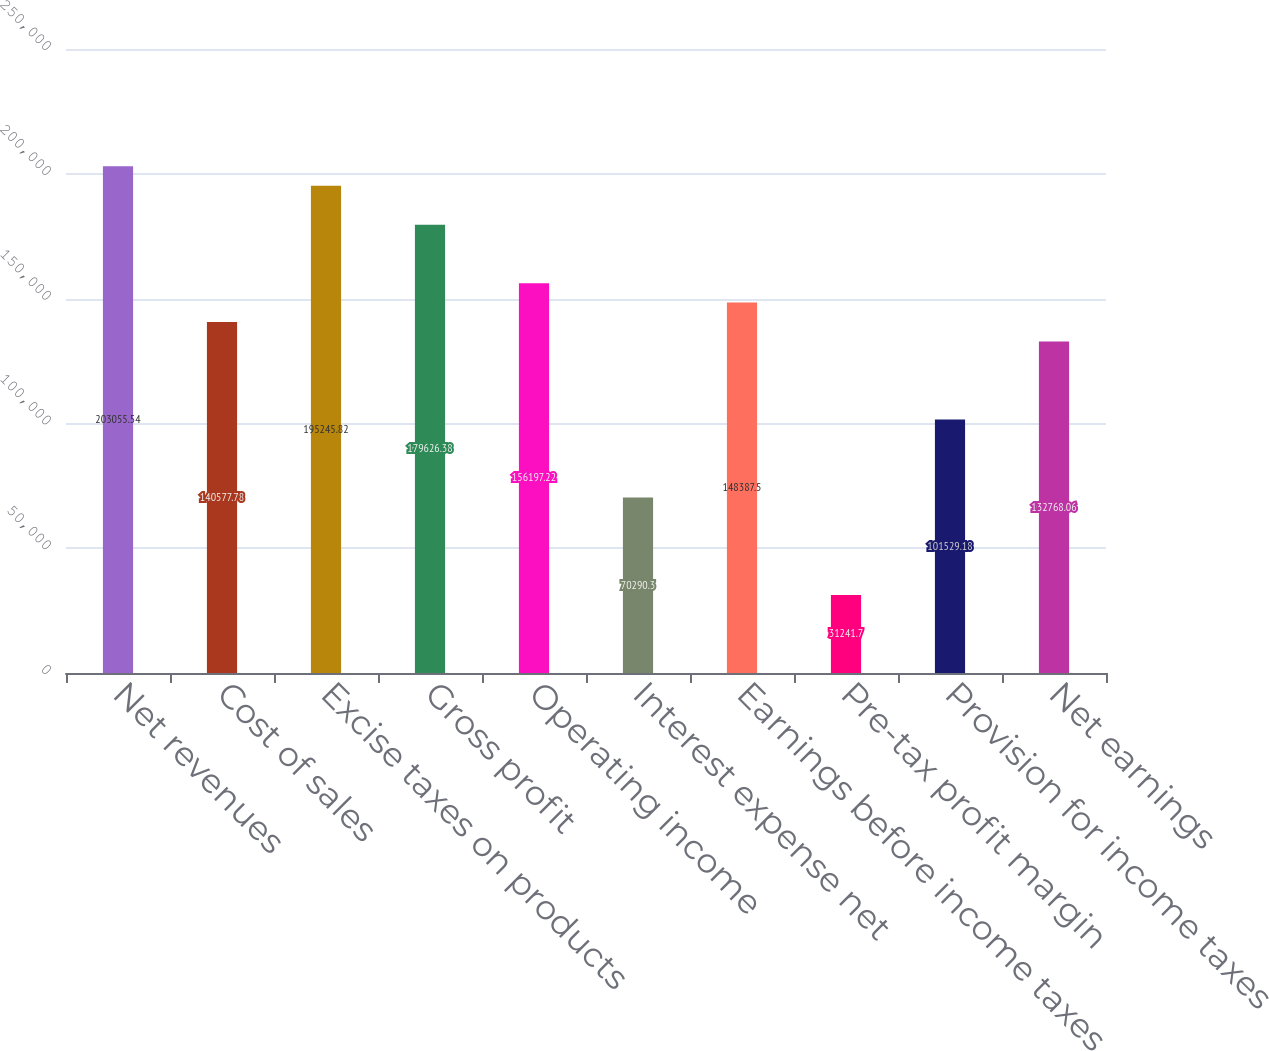Convert chart to OTSL. <chart><loc_0><loc_0><loc_500><loc_500><bar_chart><fcel>Net revenues<fcel>Cost of sales<fcel>Excise taxes on products<fcel>Gross profit<fcel>Operating income<fcel>Interest expense net<fcel>Earnings before income taxes<fcel>Pre-tax profit margin<fcel>Provision for income taxes<fcel>Net earnings<nl><fcel>203056<fcel>140578<fcel>195246<fcel>179626<fcel>156197<fcel>70290.3<fcel>148388<fcel>31241.7<fcel>101529<fcel>132768<nl></chart> 